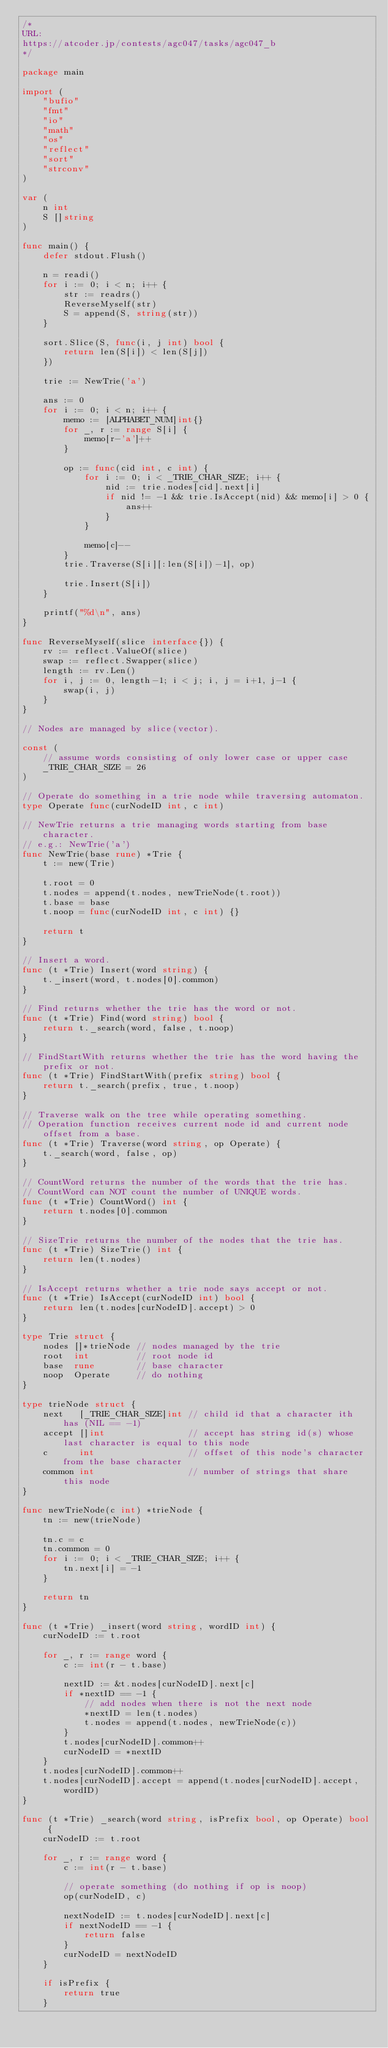<code> <loc_0><loc_0><loc_500><loc_500><_Go_>/*
URL:
https://atcoder.jp/contests/agc047/tasks/agc047_b
*/

package main

import (
	"bufio"
	"fmt"
	"io"
	"math"
	"os"
	"reflect"
	"sort"
	"strconv"
)

var (
	n int
	S []string
)

func main() {
	defer stdout.Flush()

	n = readi()
	for i := 0; i < n; i++ {
		str := readrs()
		ReverseMyself(str)
		S = append(S, string(str))
	}

	sort.Slice(S, func(i, j int) bool {
		return len(S[i]) < len(S[j])
	})

	trie := NewTrie('a')

	ans := 0
	for i := 0; i < n; i++ {
		memo := [ALPHABET_NUM]int{}
		for _, r := range S[i] {
			memo[r-'a']++
		}

		op := func(cid int, c int) {
			for i := 0; i < _TRIE_CHAR_SIZE; i++ {
				nid := trie.nodes[cid].next[i]
				if nid != -1 && trie.IsAccept(nid) && memo[i] > 0 {
					ans++
				}
			}

			memo[c]--
		}
		trie.Traverse(S[i][:len(S[i])-1], op)

		trie.Insert(S[i])
	}

	printf("%d\n", ans)
}

func ReverseMyself(slice interface{}) {
	rv := reflect.ValueOf(slice)
	swap := reflect.Swapper(slice)
	length := rv.Len()
	for i, j := 0, length-1; i < j; i, j = i+1, j-1 {
		swap(i, j)
	}
}

// Nodes are managed by slice(vector).

const (
	// assume words consisting of only lower case or upper case
	_TRIE_CHAR_SIZE = 26
)

// Operate do something in a trie node while traversing automaton.
type Operate func(curNodeID int, c int)

// NewTrie returns a trie managing words starting from base character.
// e.g.: NewTrie('a')
func NewTrie(base rune) *Trie {
	t := new(Trie)

	t.root = 0
	t.nodes = append(t.nodes, newTrieNode(t.root))
	t.base = base
	t.noop = func(curNodeID int, c int) {}

	return t
}

// Insert a word.
func (t *Trie) Insert(word string) {
	t._insert(word, t.nodes[0].common)
}

// Find returns whether the trie has the word or not.
func (t *Trie) Find(word string) bool {
	return t._search(word, false, t.noop)
}

// FindStartWith returns whether the trie has the word having the prefix or not.
func (t *Trie) FindStartWith(prefix string) bool {
	return t._search(prefix, true, t.noop)
}

// Traverse walk on the tree while operating something.
// Operation function receives current node id and current node offset from a base.
func (t *Trie) Traverse(word string, op Operate) {
	t._search(word, false, op)
}

// CountWord returns the number of the words that the trie has.
// CountWord can NOT count the number of UNIQUE words.
func (t *Trie) CountWord() int {
	return t.nodes[0].common
}

// SizeTrie returns the number of the nodes that the trie has.
func (t *Trie) SizeTrie() int {
	return len(t.nodes)
}

// IsAccept returns whether a trie node says accept or not.
func (t *Trie) IsAccept(curNodeID int) bool {
	return len(t.nodes[curNodeID].accept) > 0
}

type Trie struct {
	nodes []*trieNode // nodes managed by the trie
	root  int         // root node id
	base  rune        // base character
	noop  Operate     // do nothing
}

type trieNode struct {
	next   [_TRIE_CHAR_SIZE]int // child id that a character ith has (NIL == -1)
	accept []int                // accept has string id(s) whose last character is equal to this node
	c      int                  // offset of this node's character from the base character
	common int                  // number of strings that share this node
}

func newTrieNode(c int) *trieNode {
	tn := new(trieNode)

	tn.c = c
	tn.common = 0
	for i := 0; i < _TRIE_CHAR_SIZE; i++ {
		tn.next[i] = -1
	}

	return tn
}

func (t *Trie) _insert(word string, wordID int) {
	curNodeID := t.root

	for _, r := range word {
		c := int(r - t.base)

		nextID := &t.nodes[curNodeID].next[c]
		if *nextID == -1 {
			// add nodes when there is not the next node
			*nextID = len(t.nodes)
			t.nodes = append(t.nodes, newTrieNode(c))
		}
		t.nodes[curNodeID].common++
		curNodeID = *nextID
	}
	t.nodes[curNodeID].common++
	t.nodes[curNodeID].accept = append(t.nodes[curNodeID].accept, wordID)
}

func (t *Trie) _search(word string, isPrefix bool, op Operate) bool {
	curNodeID := t.root

	for _, r := range word {
		c := int(r - t.base)

		// operate something (do nothing if op is noop)
		op(curNodeID, c)

		nextNodeID := t.nodes[curNodeID].next[c]
		if nextNodeID == -1 {
			return false
		}
		curNodeID = nextNodeID
	}

	if isPrefix {
		return true
	}
</code> 